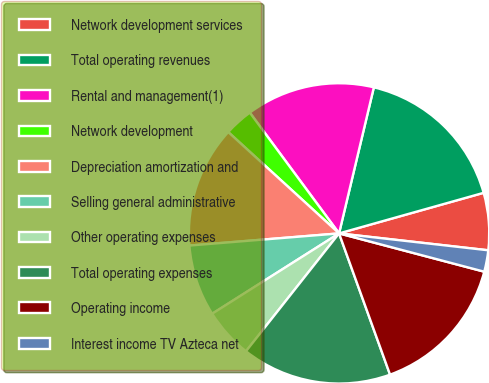Convert chart. <chart><loc_0><loc_0><loc_500><loc_500><pie_chart><fcel>Network development services<fcel>Total operating revenues<fcel>Rental and management(1)<fcel>Network development<fcel>Depreciation amortization and<fcel>Selling general administrative<fcel>Other operating expenses<fcel>Total operating expenses<fcel>Operating income<fcel>Interest income TV Azteca net<nl><fcel>6.15%<fcel>16.92%<fcel>13.85%<fcel>3.08%<fcel>13.08%<fcel>7.69%<fcel>5.38%<fcel>16.15%<fcel>15.38%<fcel>2.31%<nl></chart> 